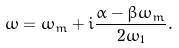Convert formula to latex. <formula><loc_0><loc_0><loc_500><loc_500>\omega = \omega _ { m } + i \frac { \alpha - \beta \omega _ { m } } { 2 \omega _ { 1 } } .</formula> 